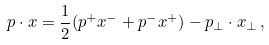<formula> <loc_0><loc_0><loc_500><loc_500>p \cdot x = \frac { 1 } { 2 } ( p ^ { + } x ^ { - } + p ^ { - } x ^ { + } ) - p _ { \perp } \cdot x _ { \perp } \, ,</formula> 